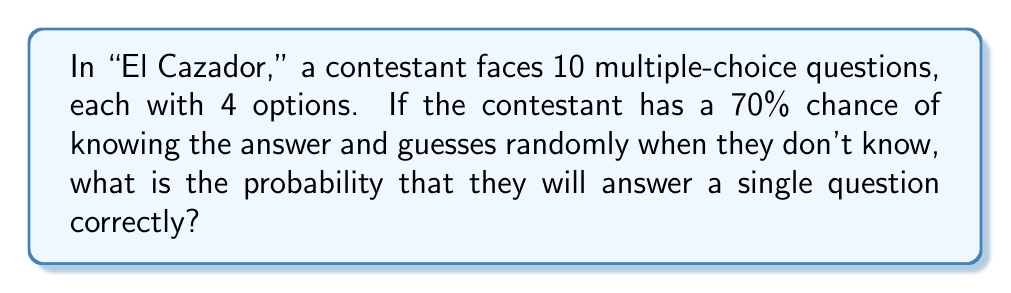Teach me how to tackle this problem. Let's approach this step-by-step:

1) There are two ways the contestant can answer correctly:
   a) They know the answer (70% chance)
   b) They don't know the answer but guess correctly

2) If they know the answer (70% chance), they'll always get it right:
   $P(\text{correct|know}) = 0.70$

3) If they don't know (30% chance), they guess randomly from 4 options:
   $P(\text{correct|don't know}) = 0.30 \cdot \frac{1}{4} = 0.075$

4) The total probability is the sum of these mutually exclusive events:

   $$P(\text{correct}) = P(\text{correct|know}) + P(\text{correct|don't know})$$
   $$P(\text{correct}) = 0.70 + 0.075 = 0.775$$

5) Convert to a percentage:
   $0.775 \cdot 100\% = 77.5\%$
Answer: 77.5% 